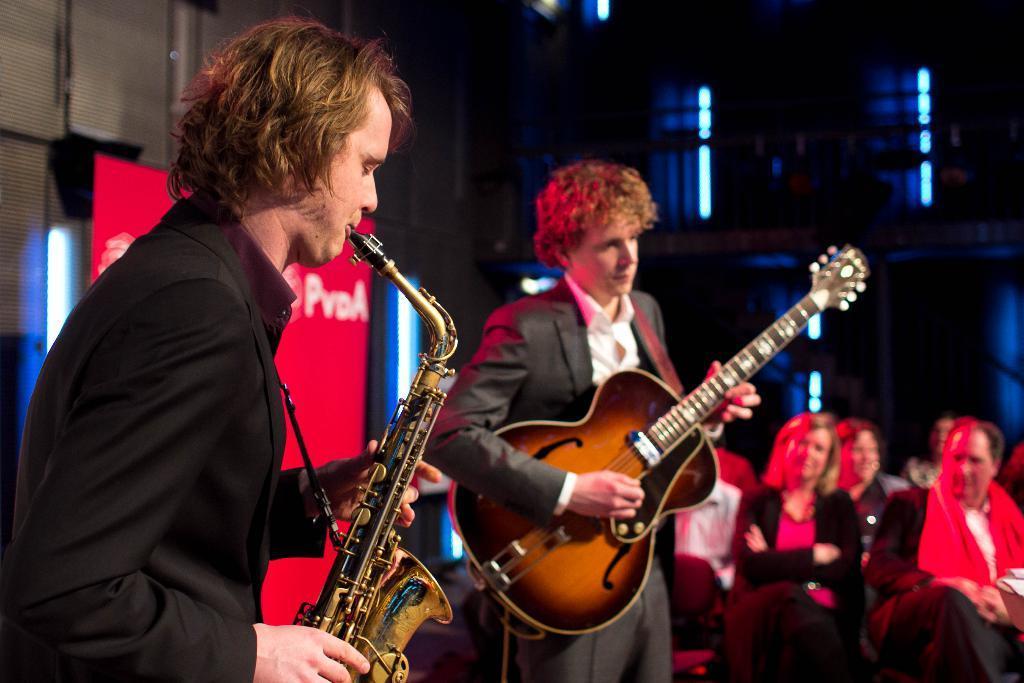How would you summarize this image in a sentence or two? These two persons standing,This person holding guitar. This person playing musical instrument. These persons sitting. On the background we can see banner. 